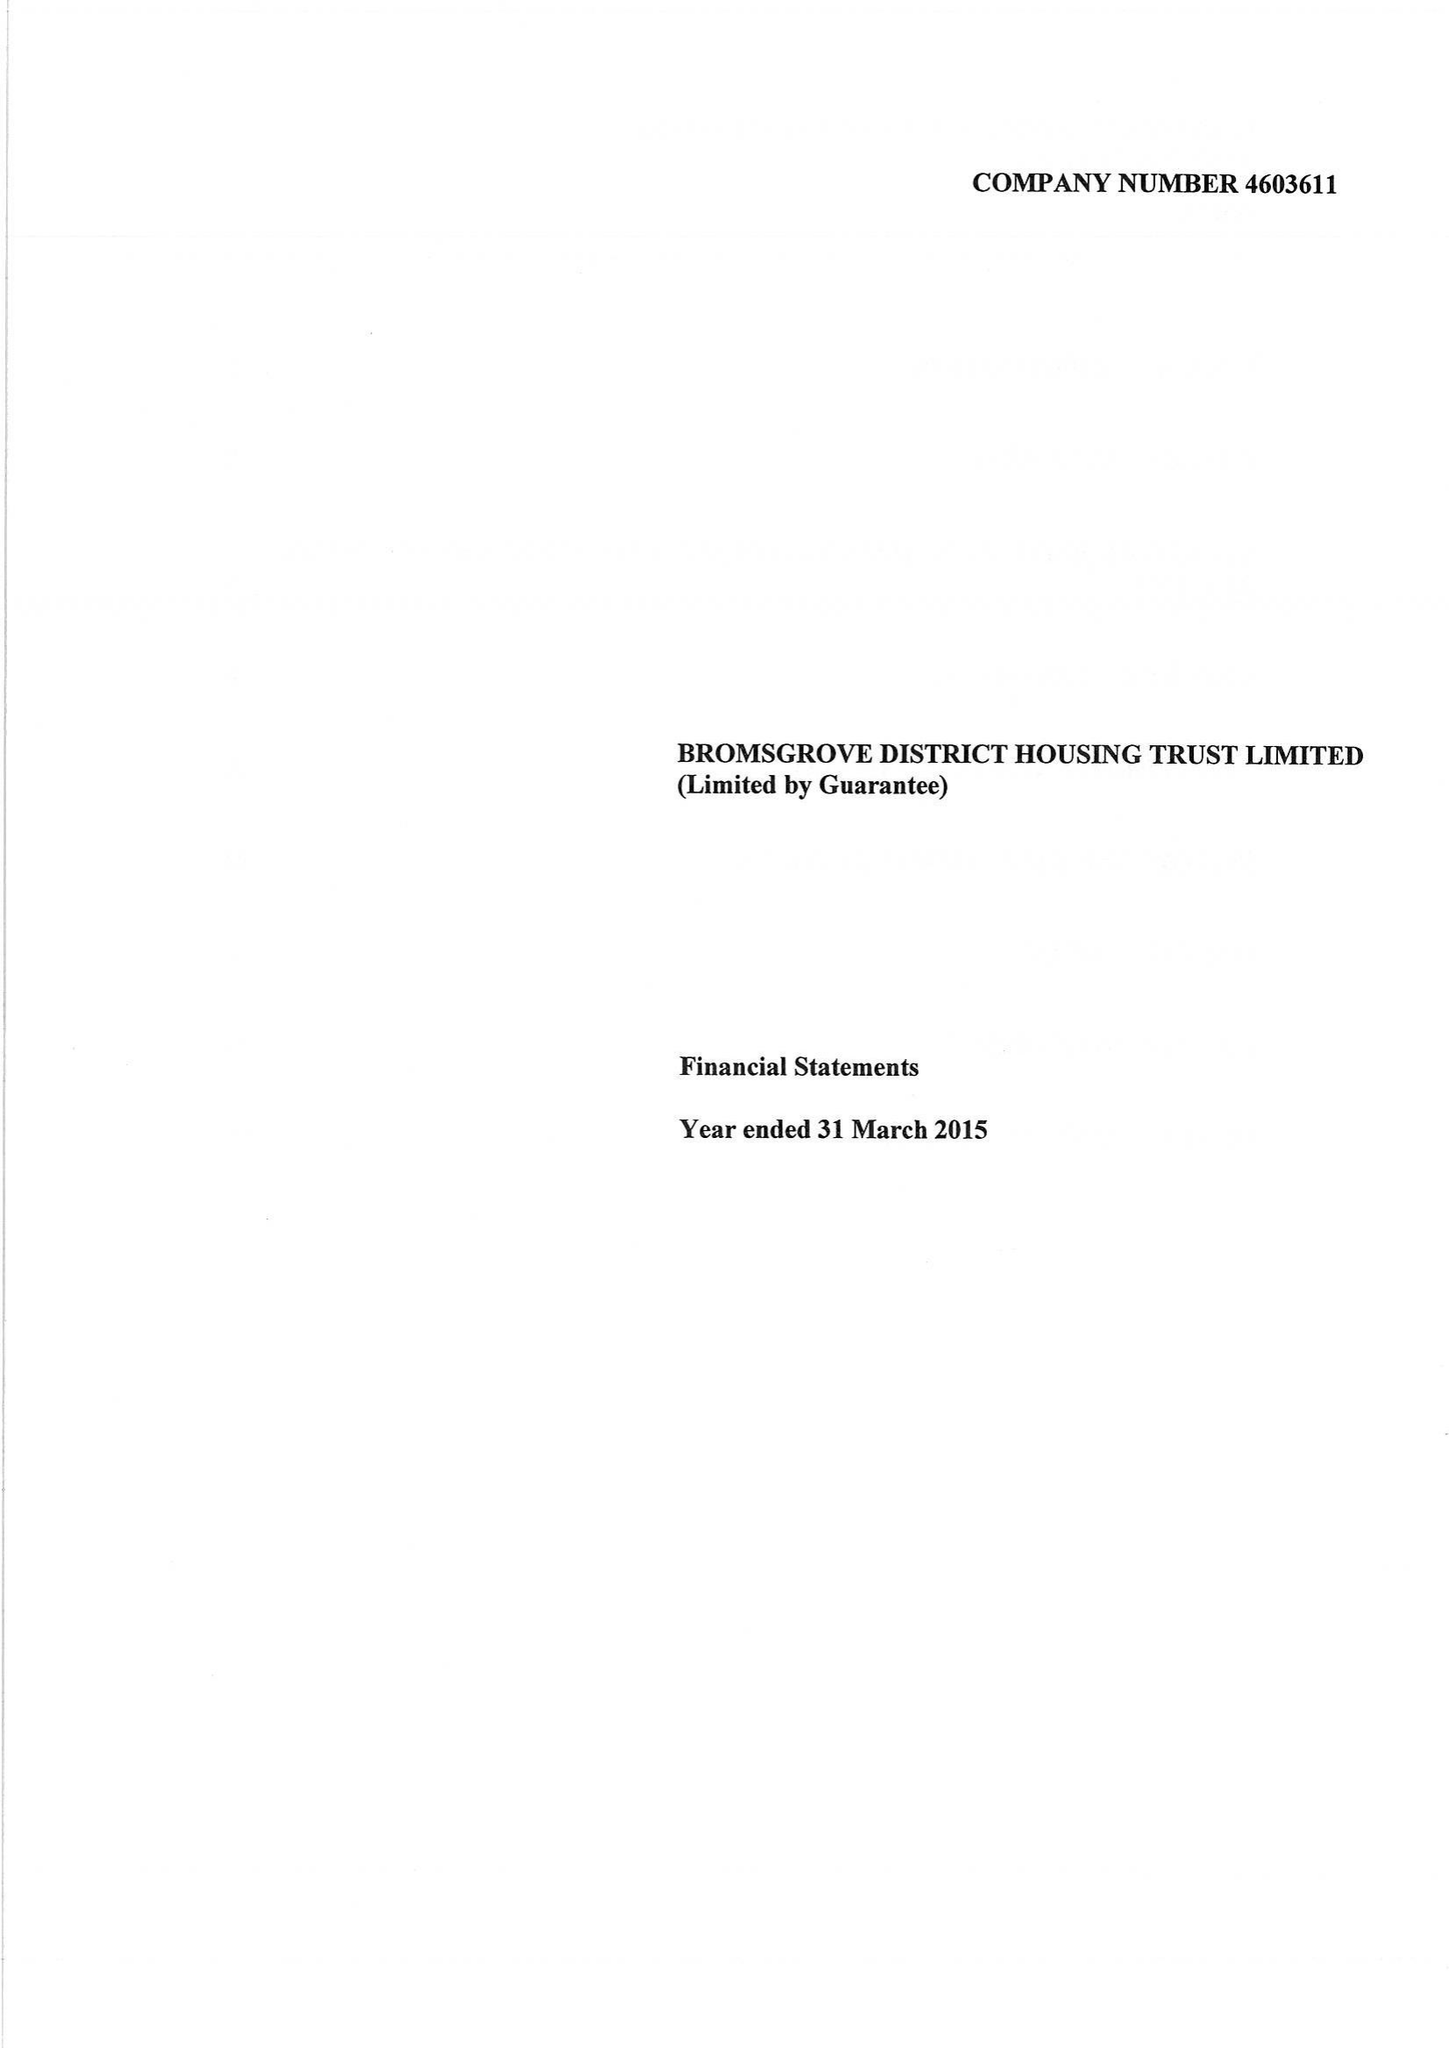What is the value for the address__postcode?
Answer the question using a single word or phrase. B60 3DJ 